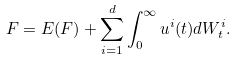Convert formula to latex. <formula><loc_0><loc_0><loc_500><loc_500>F = E ( F ) + \sum _ { i = 1 } ^ { d } \int _ { 0 } ^ { \infty } u ^ { i } ( t ) d W _ { t } ^ { i } .</formula> 